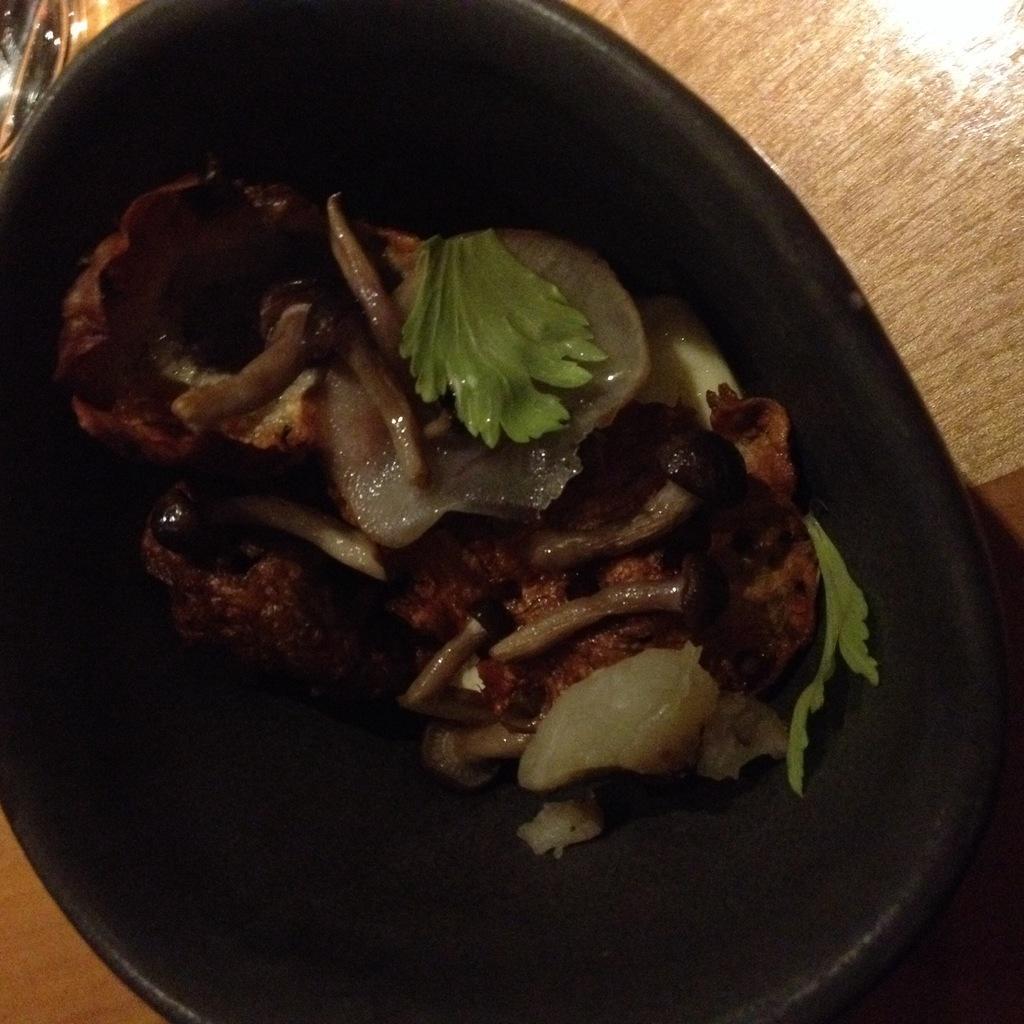Please provide a concise description of this image. In the foreground of this image, there is some food in a black bowl which is on a wooden surface. 